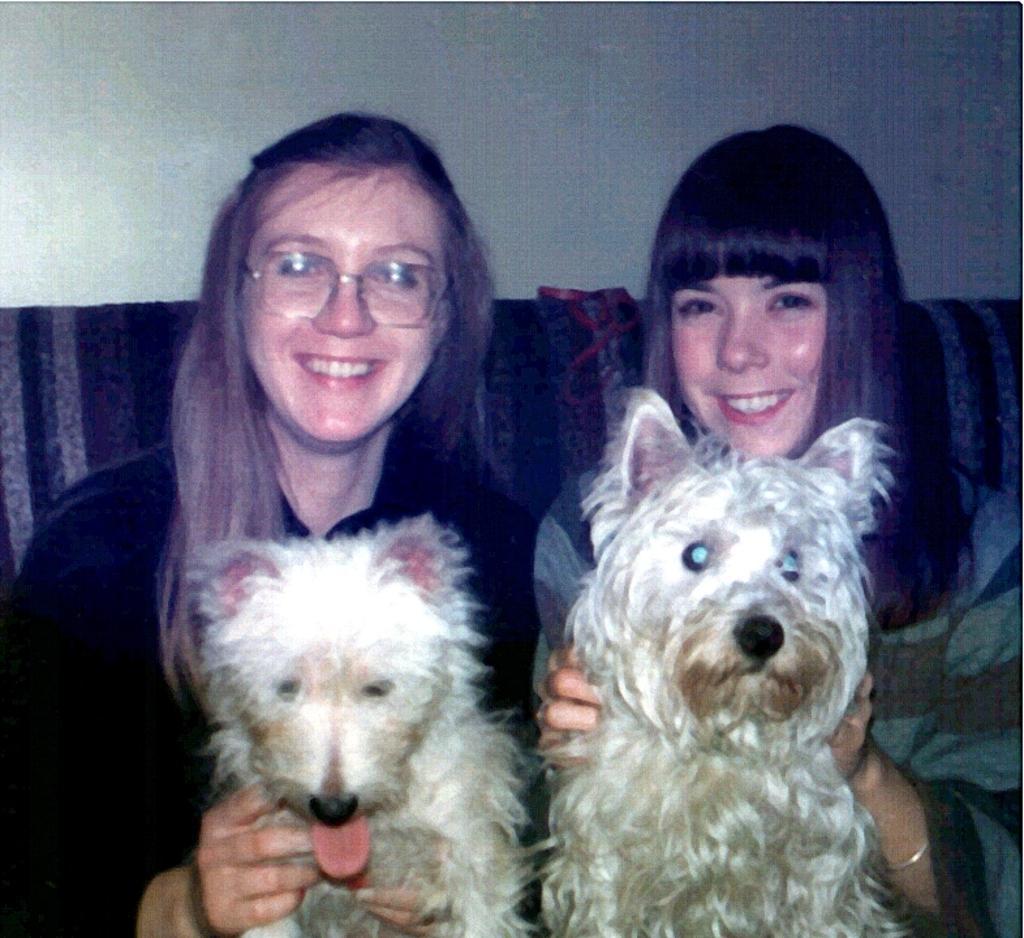Could you give a brief overview of what you see in this image? In this image I can see two persons holding two dogs. The dogs are in cream and brown color and the person is wearing black color dress, background I can see the wall in white color. 